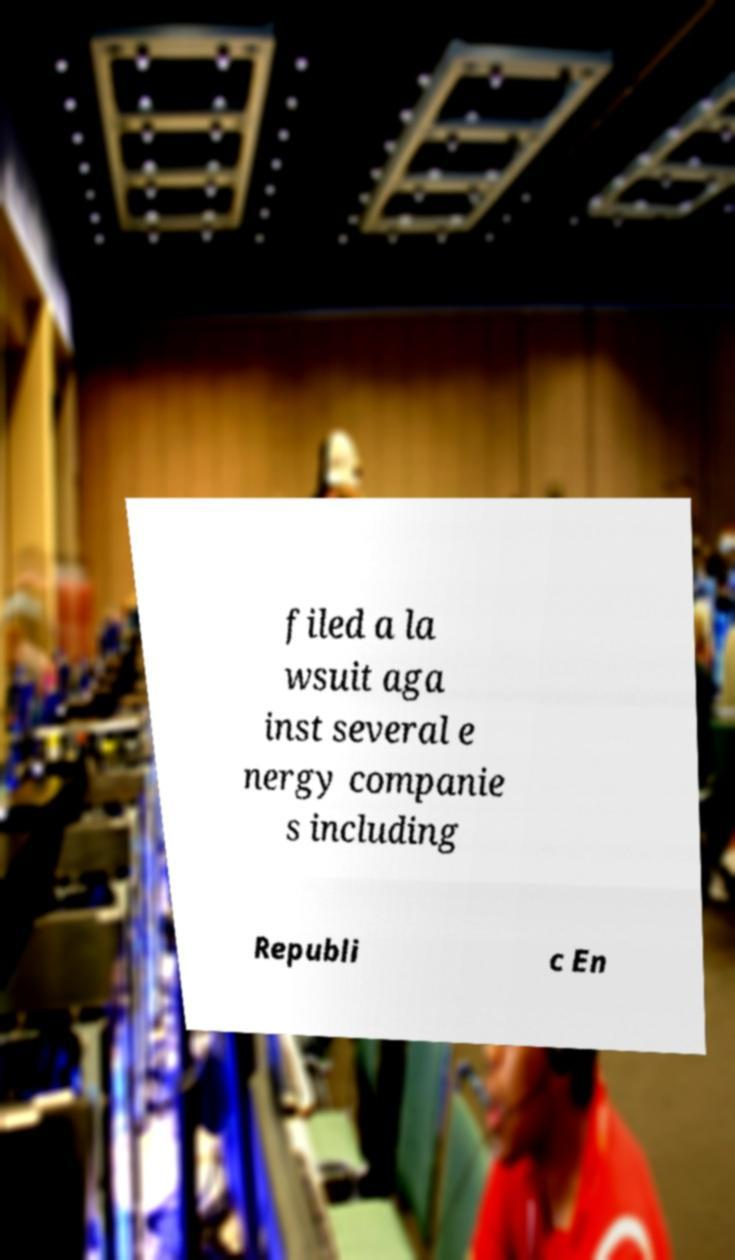I need the written content from this picture converted into text. Can you do that? filed a la wsuit aga inst several e nergy companie s including Republi c En 